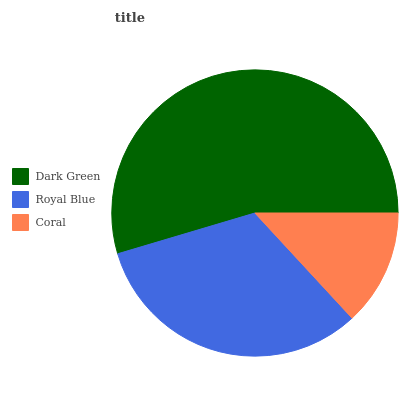Is Coral the minimum?
Answer yes or no. Yes. Is Dark Green the maximum?
Answer yes or no. Yes. Is Royal Blue the minimum?
Answer yes or no. No. Is Royal Blue the maximum?
Answer yes or no. No. Is Dark Green greater than Royal Blue?
Answer yes or no. Yes. Is Royal Blue less than Dark Green?
Answer yes or no. Yes. Is Royal Blue greater than Dark Green?
Answer yes or no. No. Is Dark Green less than Royal Blue?
Answer yes or no. No. Is Royal Blue the high median?
Answer yes or no. Yes. Is Royal Blue the low median?
Answer yes or no. Yes. Is Coral the high median?
Answer yes or no. No. Is Dark Green the low median?
Answer yes or no. No. 